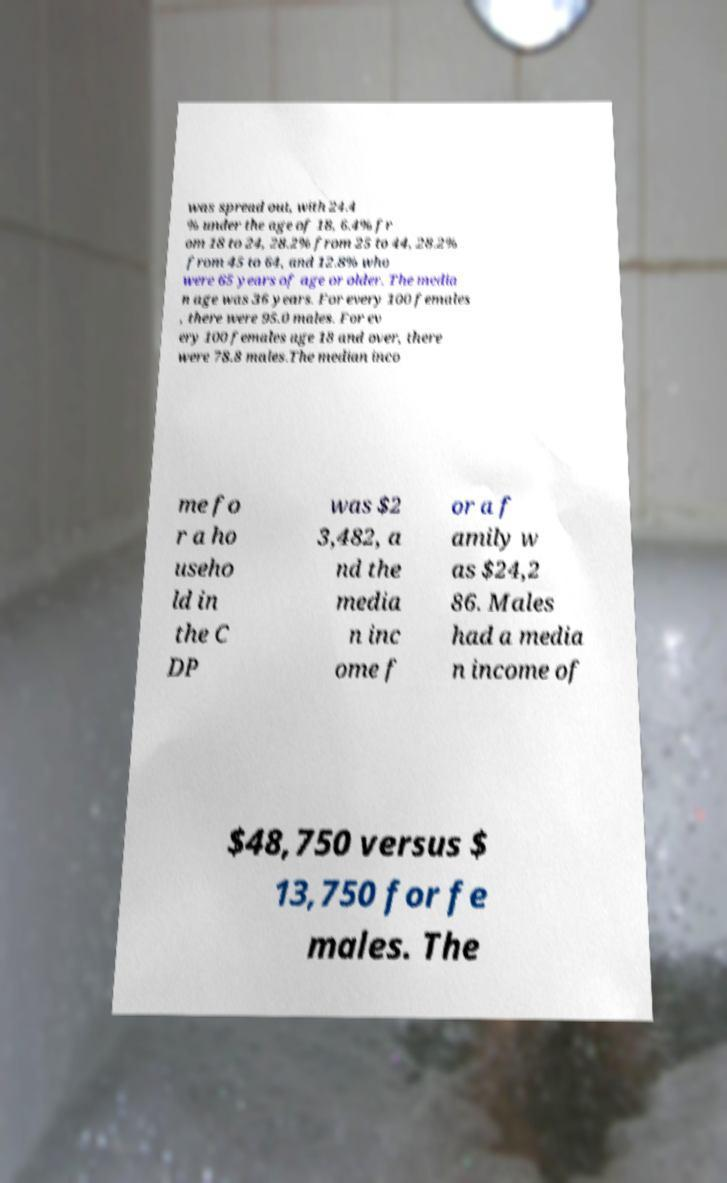Could you extract and type out the text from this image? was spread out, with 24.4 % under the age of 18, 6.4% fr om 18 to 24, 28.2% from 25 to 44, 28.2% from 45 to 64, and 12.8% who were 65 years of age or older. The media n age was 36 years. For every 100 females , there were 95.0 males. For ev ery 100 females age 18 and over, there were 78.8 males.The median inco me fo r a ho useho ld in the C DP was $2 3,482, a nd the media n inc ome f or a f amily w as $24,2 86. Males had a media n income of $48,750 versus $ 13,750 for fe males. The 